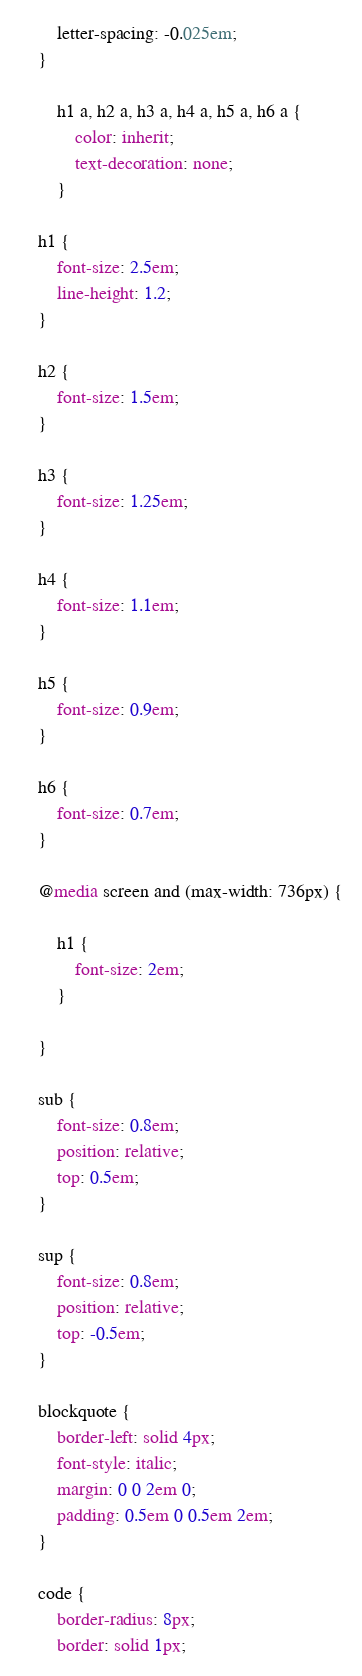Convert code to text. <code><loc_0><loc_0><loc_500><loc_500><_CSS_>		letter-spacing: -0.025em;
	}

		h1 a, h2 a, h3 a, h4 a, h5 a, h6 a {
			color: inherit;
			text-decoration: none;
		}

	h1 {
		font-size: 2.5em;
		line-height: 1.2;
	}

	h2 {
		font-size: 1.5em;
	}

	h3 {
		font-size: 1.25em;
	}

	h4 {
		font-size: 1.1em;
	}

	h5 {
		font-size: 0.9em;
	}

	h6 {
		font-size: 0.7em;
	}

	@media screen and (max-width: 736px) {

		h1 {
			font-size: 2em;
		}

	}

	sub {
		font-size: 0.8em;
		position: relative;
		top: 0.5em;
	}

	sup {
		font-size: 0.8em;
		position: relative;
		top: -0.5em;
	}

	blockquote {
		border-left: solid 4px;
		font-style: italic;
		margin: 0 0 2em 0;
		padding: 0.5em 0 0.5em 2em;
	}

	code {
		border-radius: 8px;
		border: solid 1px;</code> 